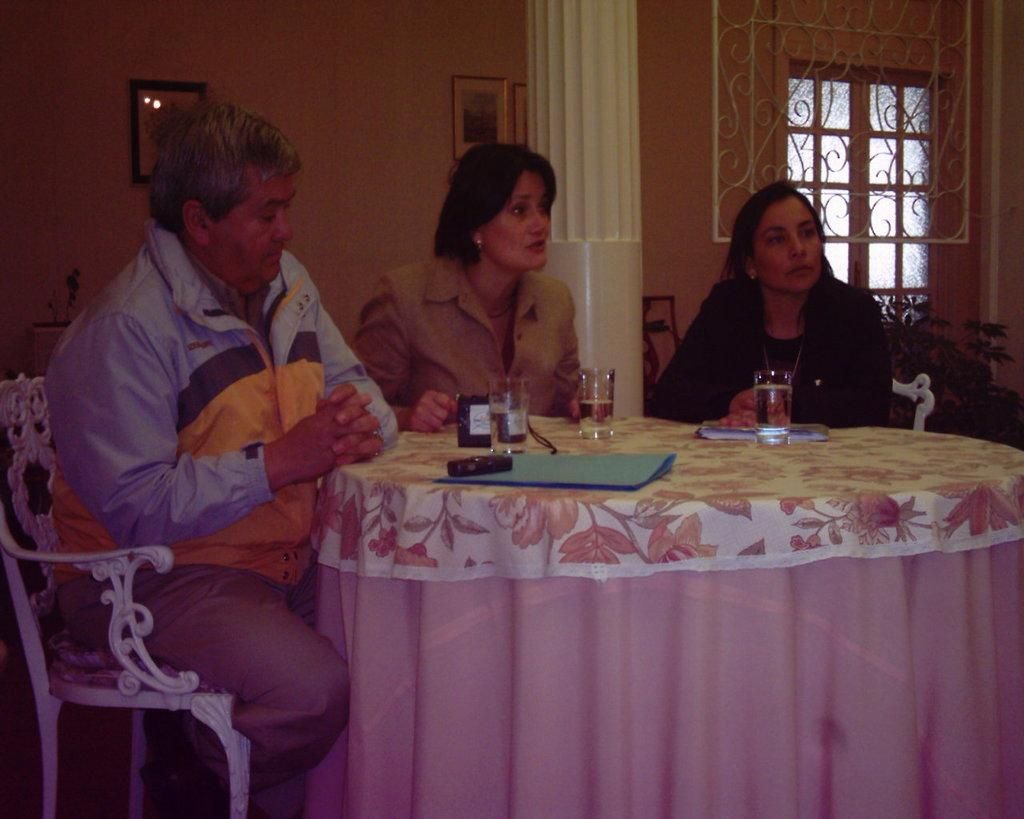How many people are in the image? There are three persons in the image. What are the persons doing in the image? The persons are sitting around a table and having drinks. What else can be seen on the table besides the drinks? There is a file on the table. What type of pest can be seen crawling on the table in the image? There is no pest visible in the image; the table only contains a file and drinks. How does the silk affect the persons in the image? There is no silk present in the image, so it cannot affect the persons. 